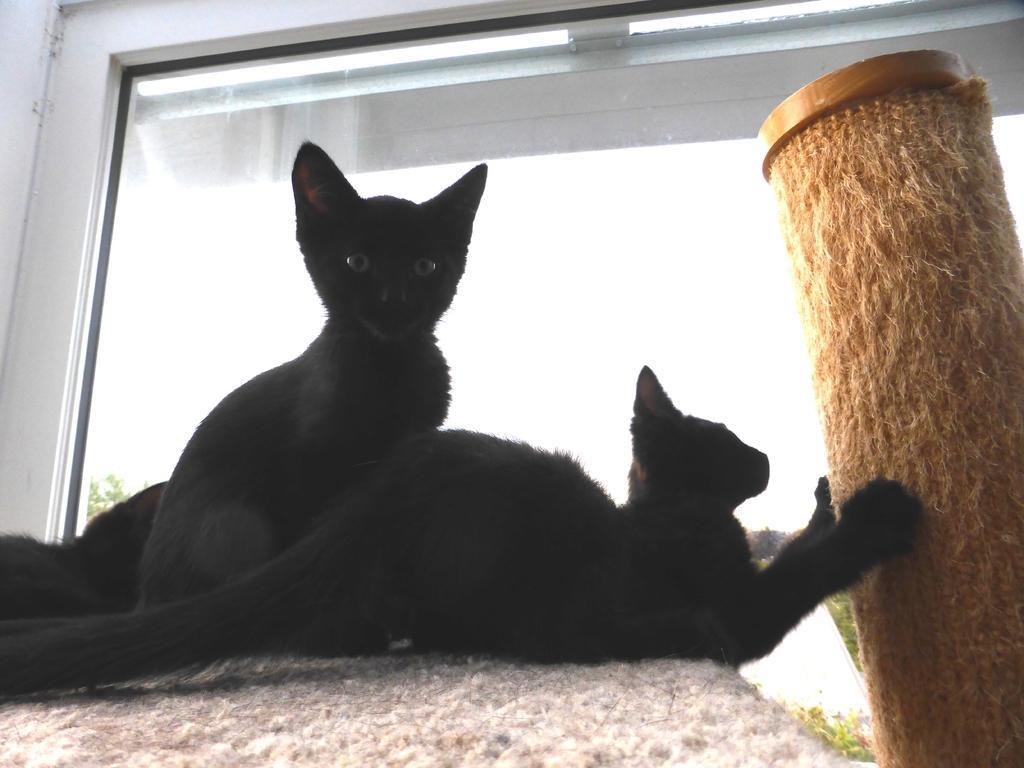In one or two sentences, can you explain what this image depicts? In this picture there are two black color kittens, sitting on the table. Beside there is a brown color straw roll. In the background we can see the glass window. 